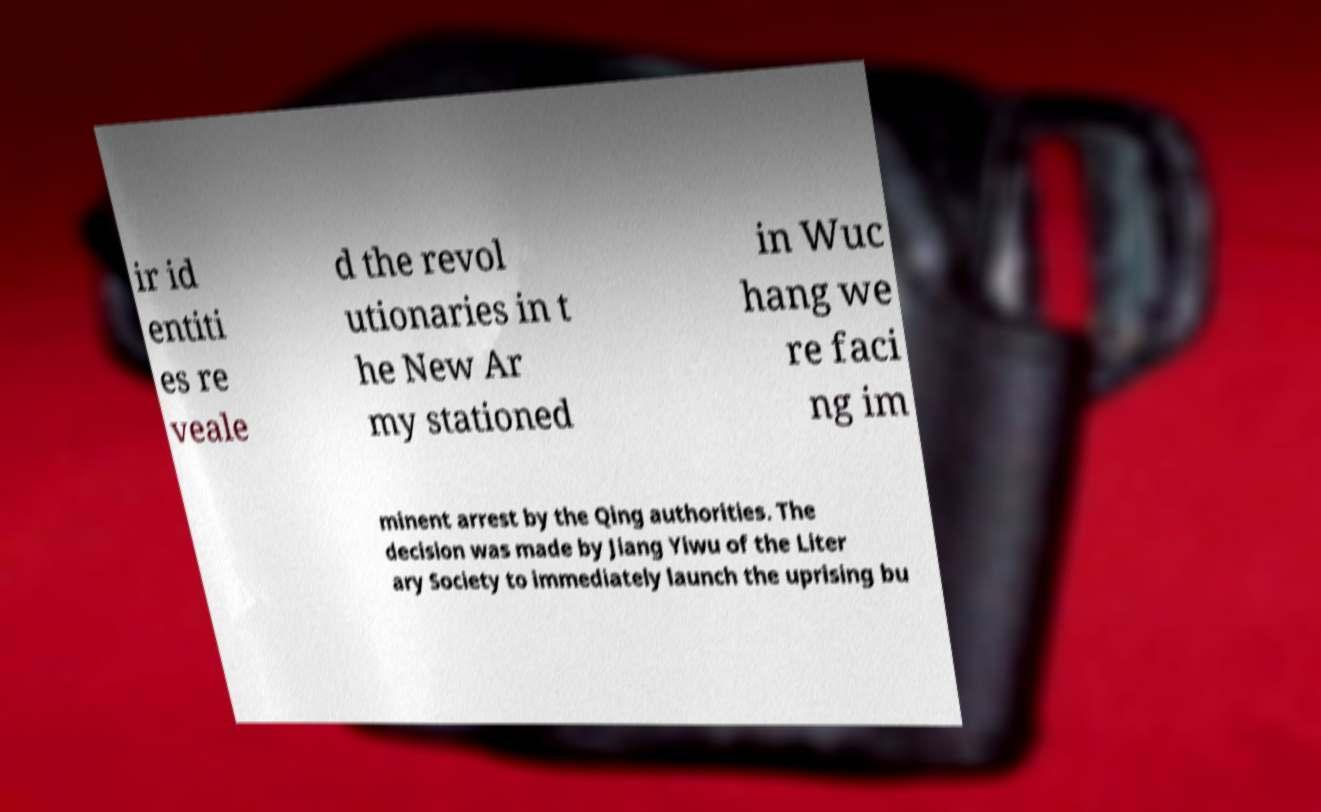There's text embedded in this image that I need extracted. Can you transcribe it verbatim? ir id entiti es re veale d the revol utionaries in t he New Ar my stationed in Wuc hang we re faci ng im minent arrest by the Qing authorities. The decision was made by Jiang Yiwu of the Liter ary Society to immediately launch the uprising bu 